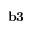Convert formula to latex. <formula><loc_0><loc_0><loc_500><loc_500>{ b 3 }</formula> 